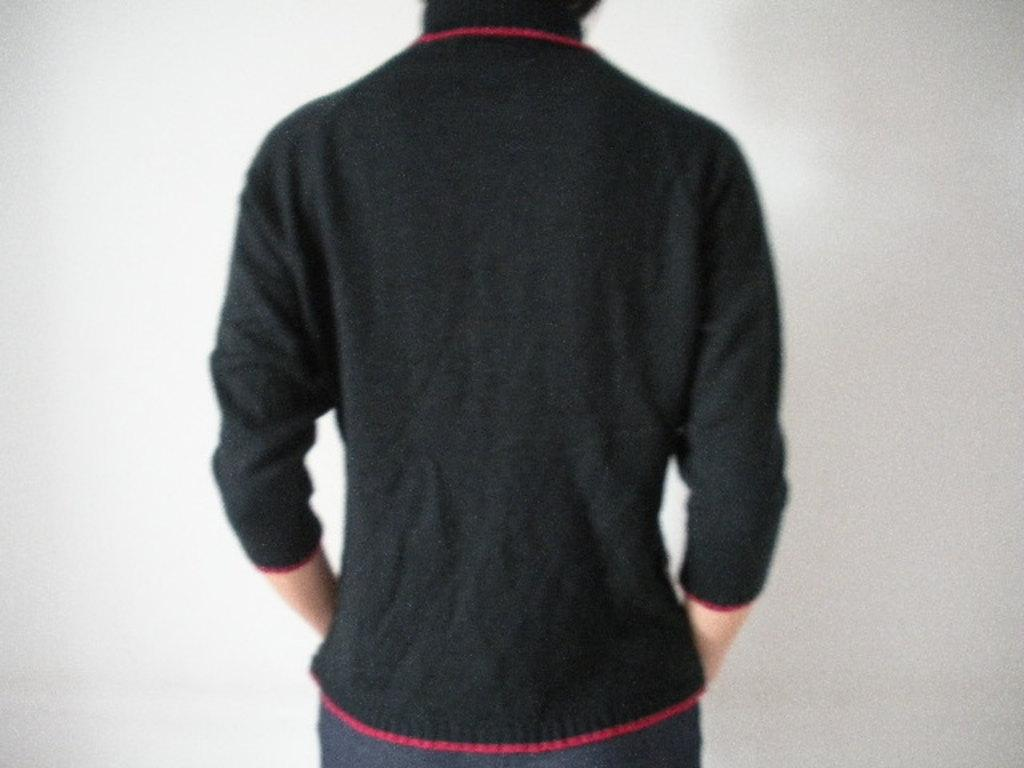Who or what is the main subject of the image? There is a person in the image. What can be observed about the background of the image? The background of the image is white in color. What flavor of ice cream is the person's son eating in the image? There is no person's son or ice cream present in the image. What is the person's uncle doing in the image? There is no person's uncle present in the image. 